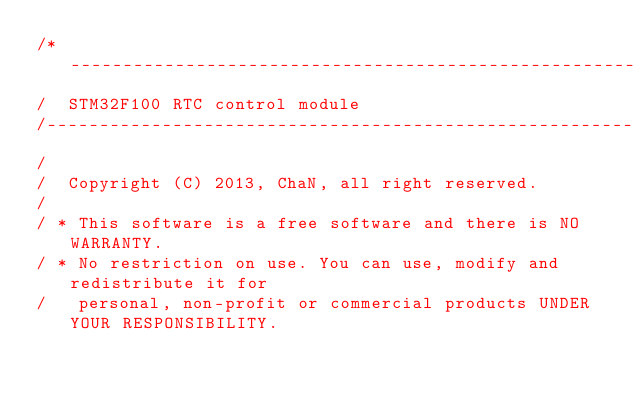Convert code to text. <code><loc_0><loc_0><loc_500><loc_500><_C_>/*------------------------------------------------------------------------/
/  STM32F100 RTC control module
/-------------------------------------------------------------------------/
/
/  Copyright (C) 2013, ChaN, all right reserved.
/
/ * This software is a free software and there is NO WARRANTY.
/ * No restriction on use. You can use, modify and redistribute it for
/   personal, non-profit or commercial products UNDER YOUR RESPONSIBILITY.</code> 